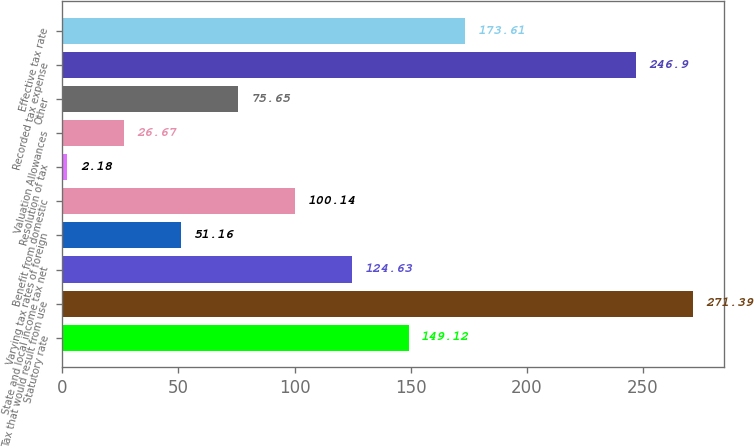<chart> <loc_0><loc_0><loc_500><loc_500><bar_chart><fcel>Statutory rate<fcel>Tax that would result from use<fcel>State and local income tax net<fcel>Varying tax rates of foreign<fcel>Benefit from domestic<fcel>Resolution of tax<fcel>Valuation Allowances<fcel>Other<fcel>Recorded tax expense<fcel>Effective tax rate<nl><fcel>149.12<fcel>271.39<fcel>124.63<fcel>51.16<fcel>100.14<fcel>2.18<fcel>26.67<fcel>75.65<fcel>246.9<fcel>173.61<nl></chart> 